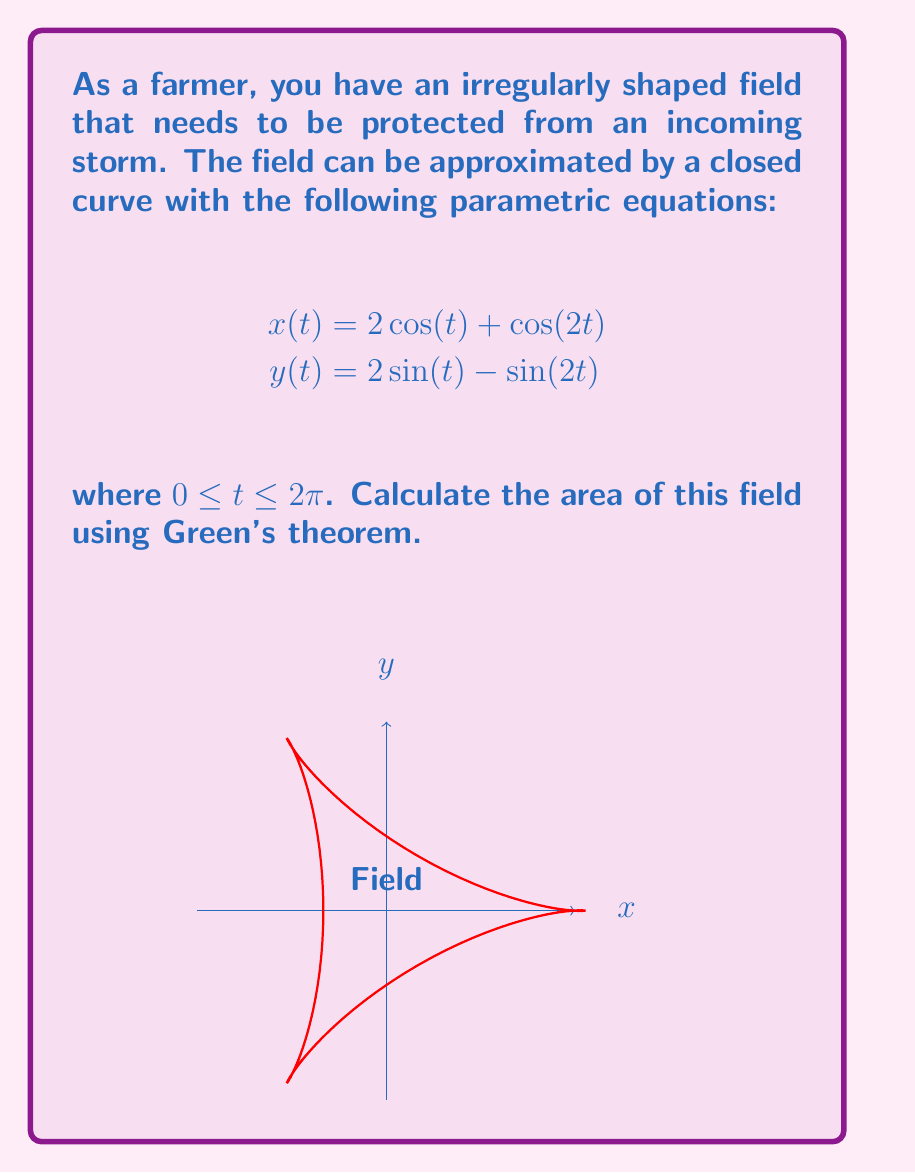What is the answer to this math problem? Let's approach this step-by-step using Green's theorem:

1) Green's theorem states that for a positively oriented, piecewise smooth, simple closed curve C in a plane, the area enclosed by C is given by:

   $$A = \frac{1}{2} \oint_C (x dy - y dx)$$

2) Given our parametric equations, we need to find $dx$ and $dy$:
   
   $$dx = (-2\sin(t) - 2\sin(2t))dt$$
   $$dy = (2\cos(t) - 2\cos(2t))dt$$

3) Now, let's substitute these into our area formula:

   $$A = \frac{1}{2} \int_0^{2\pi} [(2\cos(t) + \cos(2t))(2\cos(t) - 2\cos(2t)) - (2\sin(t) - \sin(2t))(-2\sin(t) - 2\sin(2t))] dt$$

4) Expand this:

   $$A = \frac{1}{2} \int_0^{2\pi} [4\cos^2(t) - 4\cos(t)\cos(2t) + 2\cos(t)\cos(2t) - 2\cos^2(2t) + 4\sin^2(t) + 4\sin(t)\sin(2t) - 2\sin(t)\sin(2t) - 2\sin^2(2t)] dt$$

5) Simplify using trigonometric identities:

   $$A = \frac{1}{2} \int_0^{2\pi} [4\cos^2(t) + 4\sin^2(t) - 2\cos(t)\cos(2t) + 2\sin(t)\sin(2t) - 2\cos^2(2t) - 2\sin^2(2t)] dt$$
   
   $$A = \frac{1}{2} \int_0^{2\pi} [4 - 2\cos(3t) - 2] dt = \int_0^{2\pi} [1 - \cos(3t)] dt$$

6) Integrate:

   $$A = [t - \frac{1}{3}\sin(3t)]_0^{2\pi} = 2\pi - 0 = 2\pi$$

Therefore, the area of the field is $2\pi$ square units.
Answer: $2\pi$ square units 